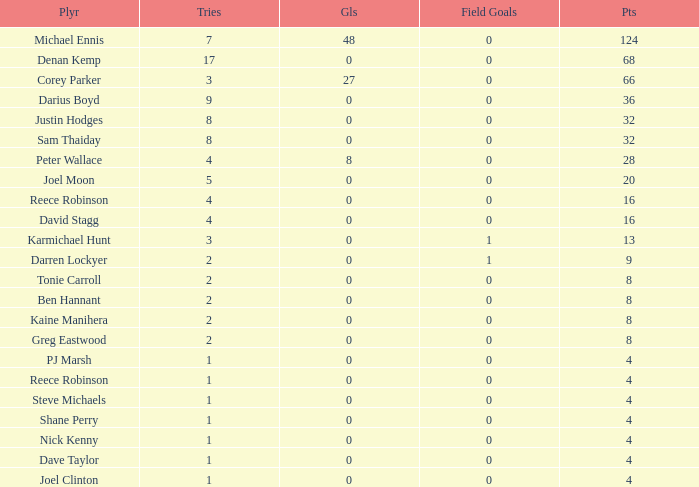How many goals did the player with under 4 points have? 0.0. 